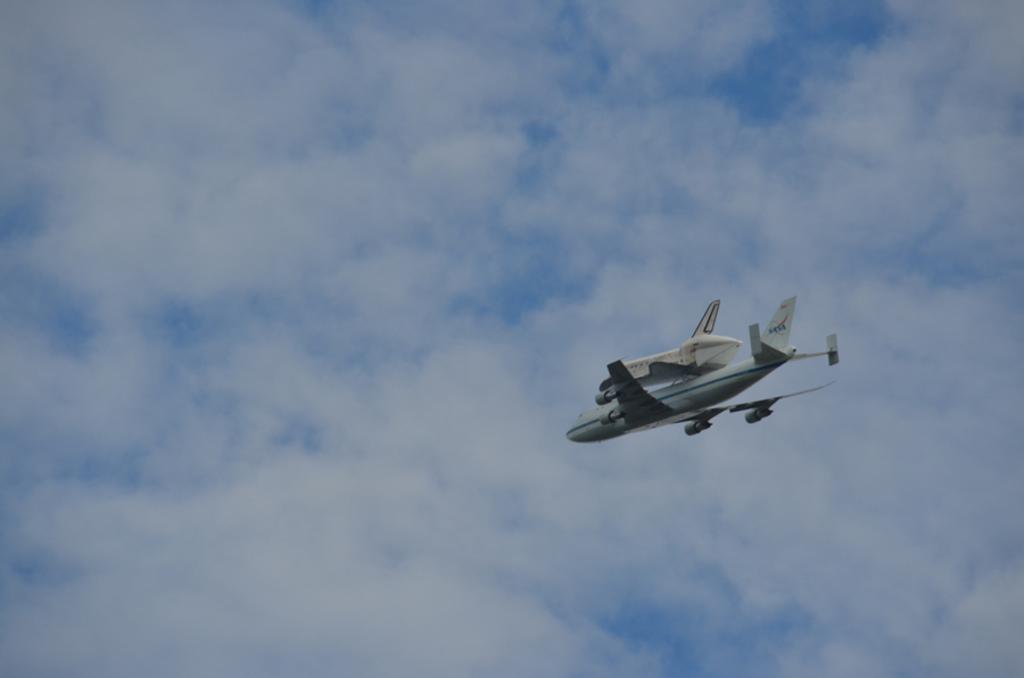Describe this image in one or two sentences. This image is taken outdoors. In the background there is a sky with clouds. In the middle of the image an airplane is flying in the sky. 